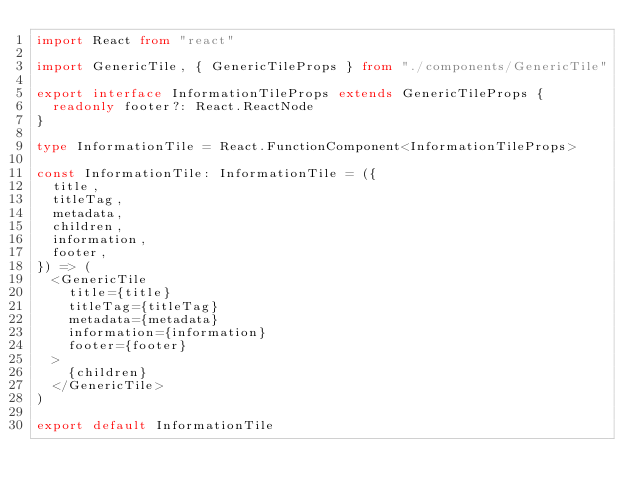<code> <loc_0><loc_0><loc_500><loc_500><_TypeScript_>import React from "react"

import GenericTile, { GenericTileProps } from "./components/GenericTile"

export interface InformationTileProps extends GenericTileProps {
  readonly footer?: React.ReactNode
}

type InformationTile = React.FunctionComponent<InformationTileProps>

const InformationTile: InformationTile = ({
  title,
  titleTag,
  metadata,
  children,
  information,
  footer,
}) => (
  <GenericTile
    title={title}
    titleTag={titleTag}
    metadata={metadata}
    information={information}
    footer={footer}
  >
    {children}
  </GenericTile>
)

export default InformationTile
</code> 